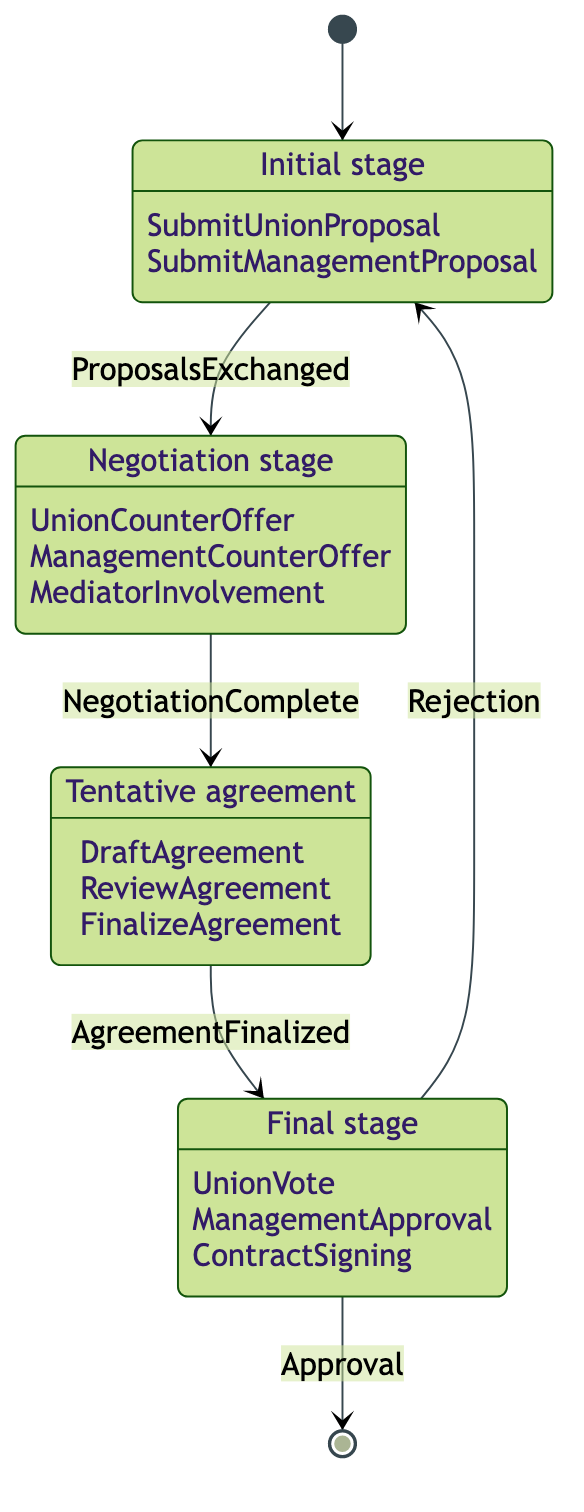What is the first state in the diagram? The first state in the diagram is indicated by the initial transition from the starting point (represented as [*]) to Proposal.
Answer: Proposal How many actions are there in the Bargaining state? The Bargaining state has three actions listed: UnionCounterOffer, ManagementCounterOffer, and MediatorInvolvement. Adding these together gives a total of three actions.
Answer: 3 What transition occurs from Agreement to Ratification? The transition from Agreement to Ratification is triggered by the event 'AgreementFinalized', which is the specific condition that must be met for the transition to occur.
Answer: AgreementFinalized Which state comes after Ratification if the contract is rejected? If the contract is rejected, the diagram shows that the next state will return to Proposal. This indicates a loop back to the initial stage after rejection.
Answer: Proposal What is the total number of states in this diagram? The diagram contains four distinct states: Proposal, Bargaining, Agreement, and Ratification. Counting these gives a total of four states.
Answer: 4 What action initiates the transition from Proposal to Bargaining? The transition from Proposal to Bargaining is initiated by the action 'ProposalsExchanged'. This action signifies that the initial proposals have been exchanged between the parties.
Answer: ProposalsExchanged What action must occur in Ratification for the contract to be signed? In the Ratification state, the action necessary for the contract to be signed is 'ContractSigning'. This action indicates the final step in the ratification process.
Answer: ContractSigning Which two states are connected directly to Ratification? The two states that are directly connected to Ratification are Agreement and Proposal. Agreement connects through 'AgreementFinalized', and Proposal connects through 'Rejection'.
Answer: Agreement, Proposal In which state does a mediator get involved? The mediator gets involved during the Bargaining state, where negotiations can become complex and require external assistance to facilitate discussions.
Answer: Bargaining 